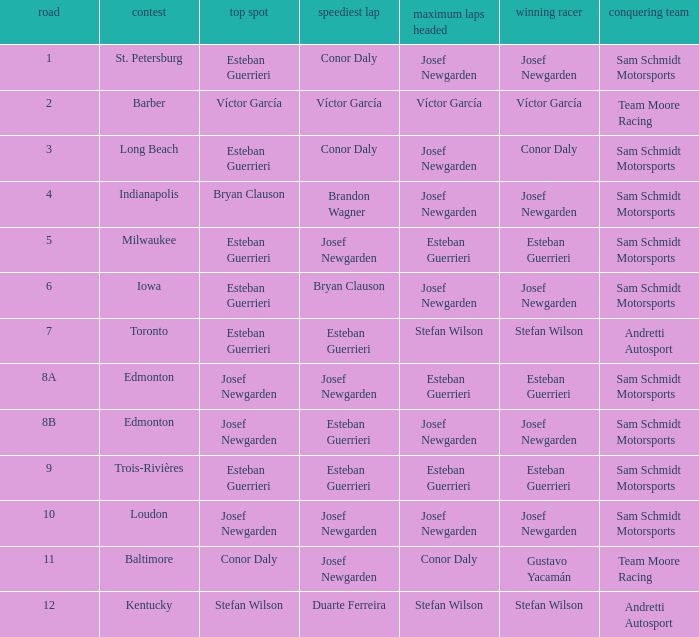Who had the pole(s) when esteban guerrieri led the most laps round 8a and josef newgarden had the fastest lap? Josef Newgarden. 